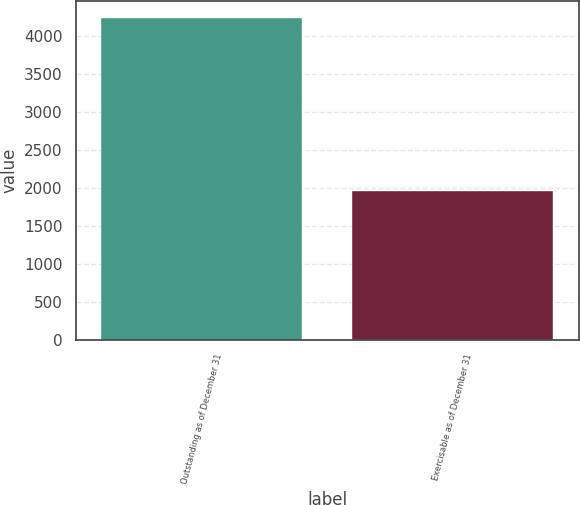<chart> <loc_0><loc_0><loc_500><loc_500><bar_chart><fcel>Outstanding as of December 31<fcel>Exercisable as of December 31<nl><fcel>4236<fcel>1959<nl></chart> 